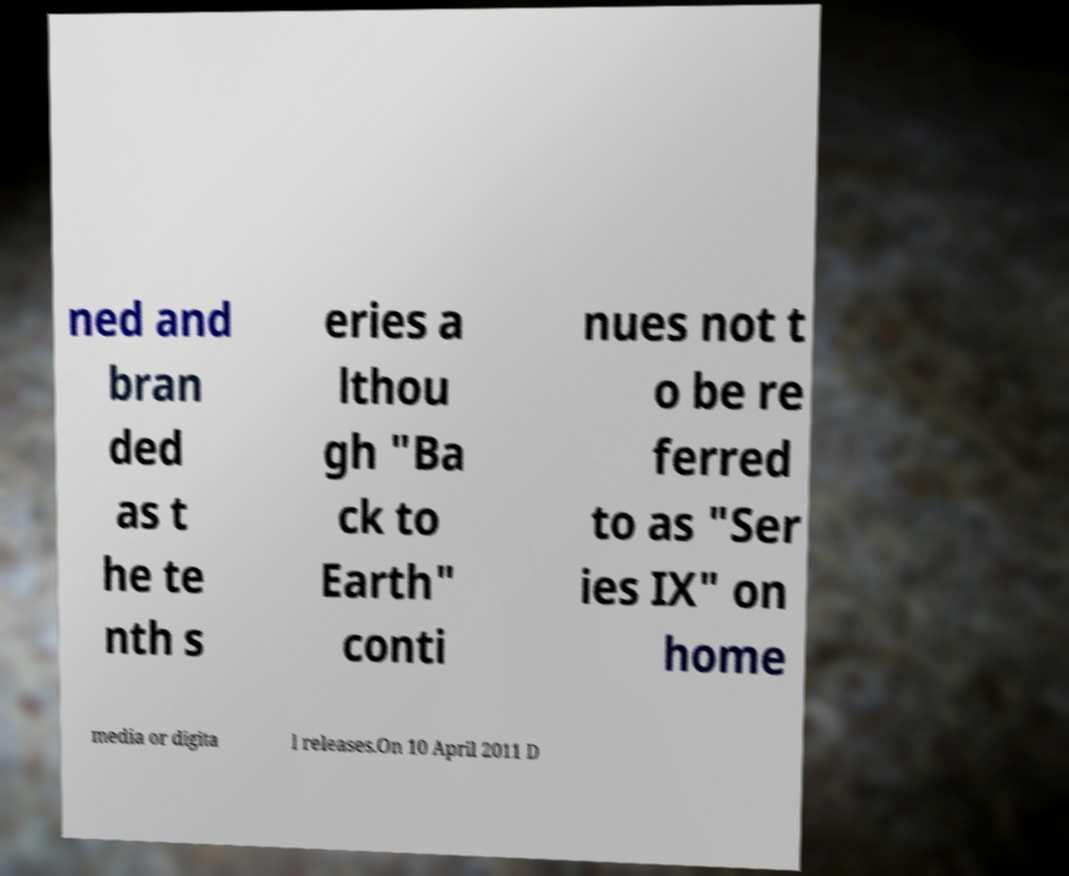For documentation purposes, I need the text within this image transcribed. Could you provide that? ned and bran ded as t he te nth s eries a lthou gh "Ba ck to Earth" conti nues not t o be re ferred to as "Ser ies IX" on home media or digita l releases.On 10 April 2011 D 